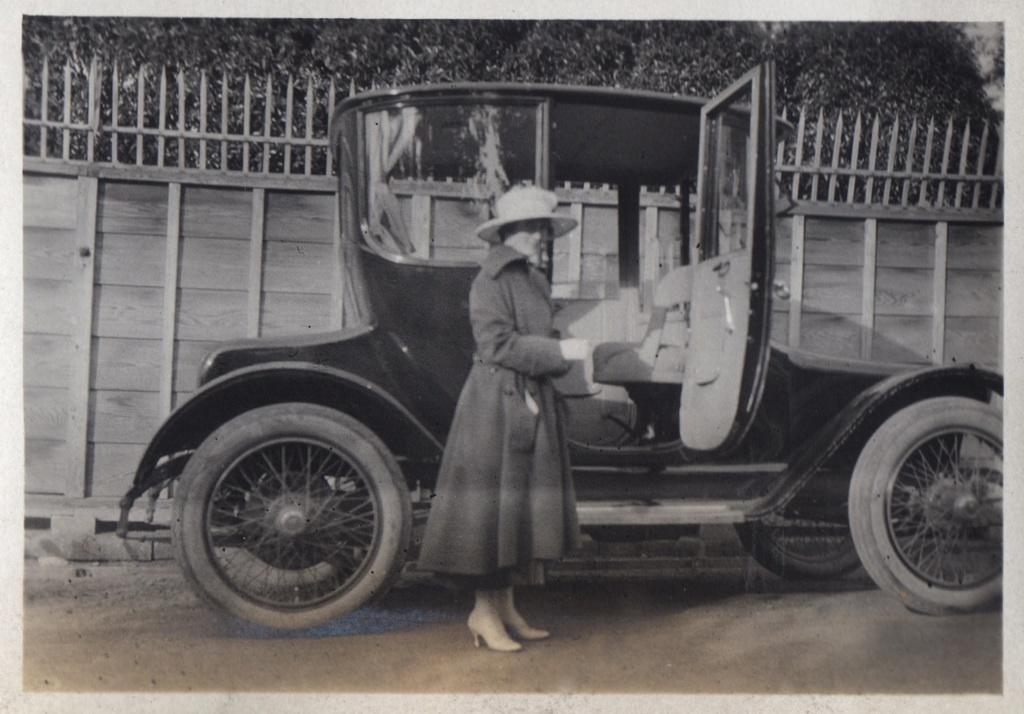Who is present in the image? There is a woman in the image. What is the woman doing in the image? The woman is standing near a car. What is the woman wearing on her head? The woman is wearing a cap. What can be seen in the background of the image? There is a fence and trees in the image. What type of steel is used to construct the kitten in the image? There is no kitten present in the image, and therefore no steel is used to construct it. What punishment is the woman receiving for standing near the car in the image? There is no indication in the image that the woman is receiving any punishment for standing near the car. 